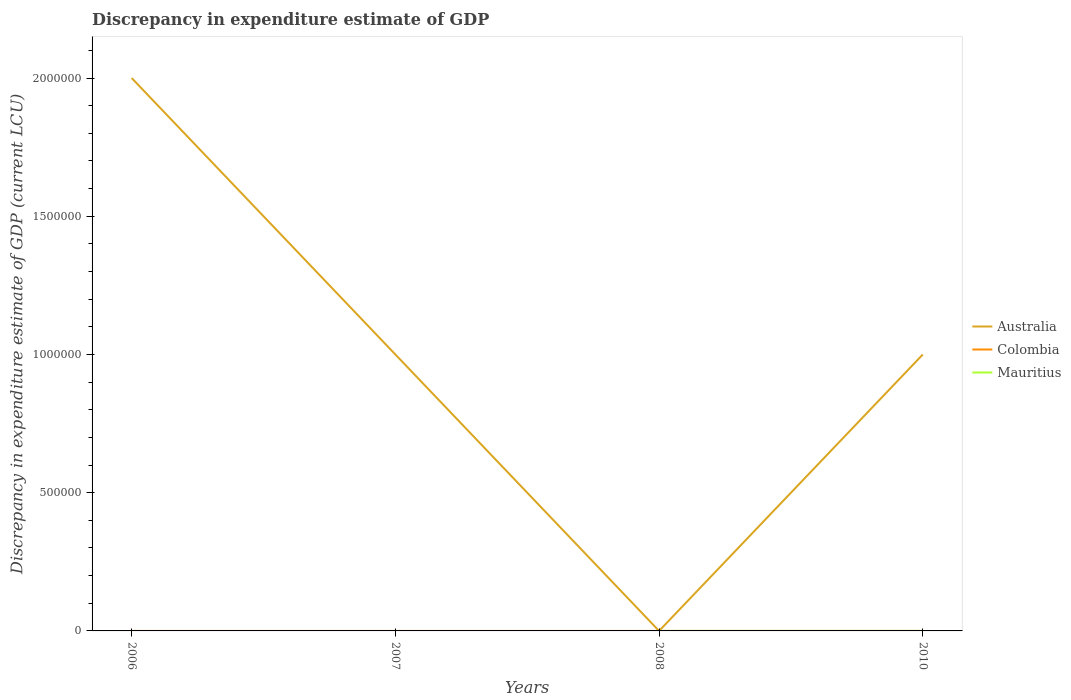Across all years, what is the maximum discrepancy in expenditure estimate of GDP in Colombia?
Provide a succinct answer. 0. What is the total discrepancy in expenditure estimate of GDP in Colombia in the graph?
Your answer should be compact. -0.01. What is the difference between the highest and the second highest discrepancy in expenditure estimate of GDP in Colombia?
Offer a terse response. 0.04. How many lines are there?
Offer a very short reply. 2. How many years are there in the graph?
Your answer should be very brief. 4. What is the difference between two consecutive major ticks on the Y-axis?
Offer a very short reply. 5.00e+05. Are the values on the major ticks of Y-axis written in scientific E-notation?
Give a very brief answer. No. Does the graph contain grids?
Offer a very short reply. No. How many legend labels are there?
Your response must be concise. 3. How are the legend labels stacked?
Your answer should be compact. Vertical. What is the title of the graph?
Offer a very short reply. Discrepancy in expenditure estimate of GDP. What is the label or title of the X-axis?
Your answer should be compact. Years. What is the label or title of the Y-axis?
Provide a succinct answer. Discrepancy in expenditure estimate of GDP (current LCU). What is the Discrepancy in expenditure estimate of GDP (current LCU) in Colombia in 2006?
Provide a short and direct response. 0.01. What is the Discrepancy in expenditure estimate of GDP (current LCU) in Colombia in 2007?
Ensure brevity in your answer.  0.01. What is the Discrepancy in expenditure estimate of GDP (current LCU) in Mauritius in 2007?
Your answer should be compact. 0. What is the Discrepancy in expenditure estimate of GDP (current LCU) of Australia in 2008?
Offer a very short reply. 9e-5. What is the Discrepancy in expenditure estimate of GDP (current LCU) in Colombia in 2008?
Offer a very short reply. 0. What is the Discrepancy in expenditure estimate of GDP (current LCU) in Mauritius in 2008?
Your answer should be compact. 0. What is the Discrepancy in expenditure estimate of GDP (current LCU) in Australia in 2010?
Provide a succinct answer. 1.00e+06. What is the Discrepancy in expenditure estimate of GDP (current LCU) of Colombia in 2010?
Provide a short and direct response. 0.04. What is the Discrepancy in expenditure estimate of GDP (current LCU) of Mauritius in 2010?
Your answer should be compact. 0. Across all years, what is the maximum Discrepancy in expenditure estimate of GDP (current LCU) of Colombia?
Your answer should be compact. 0.04. Across all years, what is the minimum Discrepancy in expenditure estimate of GDP (current LCU) of Australia?
Your response must be concise. 9e-5. What is the total Discrepancy in expenditure estimate of GDP (current LCU) of Australia in the graph?
Offer a very short reply. 4.00e+06. What is the total Discrepancy in expenditure estimate of GDP (current LCU) of Colombia in the graph?
Ensure brevity in your answer.  0.06. What is the total Discrepancy in expenditure estimate of GDP (current LCU) in Mauritius in the graph?
Keep it short and to the point. 0. What is the difference between the Discrepancy in expenditure estimate of GDP (current LCU) in Australia in 2006 and that in 2007?
Your answer should be very brief. 1.00e+06. What is the difference between the Discrepancy in expenditure estimate of GDP (current LCU) of Colombia in 2006 and that in 2007?
Ensure brevity in your answer.  -0.01. What is the difference between the Discrepancy in expenditure estimate of GDP (current LCU) of Australia in 2006 and that in 2008?
Provide a short and direct response. 2.00e+06. What is the difference between the Discrepancy in expenditure estimate of GDP (current LCU) of Colombia in 2006 and that in 2010?
Provide a succinct answer. -0.03. What is the difference between the Discrepancy in expenditure estimate of GDP (current LCU) of Australia in 2007 and that in 2008?
Ensure brevity in your answer.  1.00e+06. What is the difference between the Discrepancy in expenditure estimate of GDP (current LCU) of Colombia in 2007 and that in 2010?
Ensure brevity in your answer.  -0.02. What is the difference between the Discrepancy in expenditure estimate of GDP (current LCU) of Australia in 2008 and that in 2010?
Provide a succinct answer. -1.00e+06. What is the difference between the Discrepancy in expenditure estimate of GDP (current LCU) of Australia in 2006 and the Discrepancy in expenditure estimate of GDP (current LCU) of Colombia in 2007?
Offer a terse response. 2.00e+06. What is the difference between the Discrepancy in expenditure estimate of GDP (current LCU) in Australia in 2006 and the Discrepancy in expenditure estimate of GDP (current LCU) in Colombia in 2010?
Make the answer very short. 2.00e+06. What is the difference between the Discrepancy in expenditure estimate of GDP (current LCU) in Australia in 2007 and the Discrepancy in expenditure estimate of GDP (current LCU) in Colombia in 2010?
Your answer should be very brief. 1.00e+06. What is the difference between the Discrepancy in expenditure estimate of GDP (current LCU) of Australia in 2008 and the Discrepancy in expenditure estimate of GDP (current LCU) of Colombia in 2010?
Ensure brevity in your answer.  -0.04. What is the average Discrepancy in expenditure estimate of GDP (current LCU) in Colombia per year?
Your answer should be compact. 0.01. In the year 2006, what is the difference between the Discrepancy in expenditure estimate of GDP (current LCU) of Australia and Discrepancy in expenditure estimate of GDP (current LCU) of Colombia?
Provide a short and direct response. 2.00e+06. In the year 2007, what is the difference between the Discrepancy in expenditure estimate of GDP (current LCU) of Australia and Discrepancy in expenditure estimate of GDP (current LCU) of Colombia?
Offer a terse response. 1.00e+06. In the year 2010, what is the difference between the Discrepancy in expenditure estimate of GDP (current LCU) in Australia and Discrepancy in expenditure estimate of GDP (current LCU) in Colombia?
Offer a very short reply. 1.00e+06. What is the ratio of the Discrepancy in expenditure estimate of GDP (current LCU) of Australia in 2006 to that in 2007?
Your answer should be very brief. 2. What is the ratio of the Discrepancy in expenditure estimate of GDP (current LCU) in Australia in 2006 to that in 2008?
Provide a succinct answer. 2.22e+1. What is the ratio of the Discrepancy in expenditure estimate of GDP (current LCU) of Colombia in 2006 to that in 2010?
Keep it short and to the point. 0.22. What is the ratio of the Discrepancy in expenditure estimate of GDP (current LCU) in Australia in 2007 to that in 2008?
Keep it short and to the point. 1.11e+1. What is the ratio of the Discrepancy in expenditure estimate of GDP (current LCU) of Colombia in 2007 to that in 2010?
Your answer should be very brief. 0.39. What is the difference between the highest and the second highest Discrepancy in expenditure estimate of GDP (current LCU) of Australia?
Offer a very short reply. 1.00e+06. What is the difference between the highest and the second highest Discrepancy in expenditure estimate of GDP (current LCU) of Colombia?
Provide a succinct answer. 0.02. What is the difference between the highest and the lowest Discrepancy in expenditure estimate of GDP (current LCU) in Australia?
Provide a short and direct response. 2.00e+06. What is the difference between the highest and the lowest Discrepancy in expenditure estimate of GDP (current LCU) in Colombia?
Your answer should be compact. 0.04. 